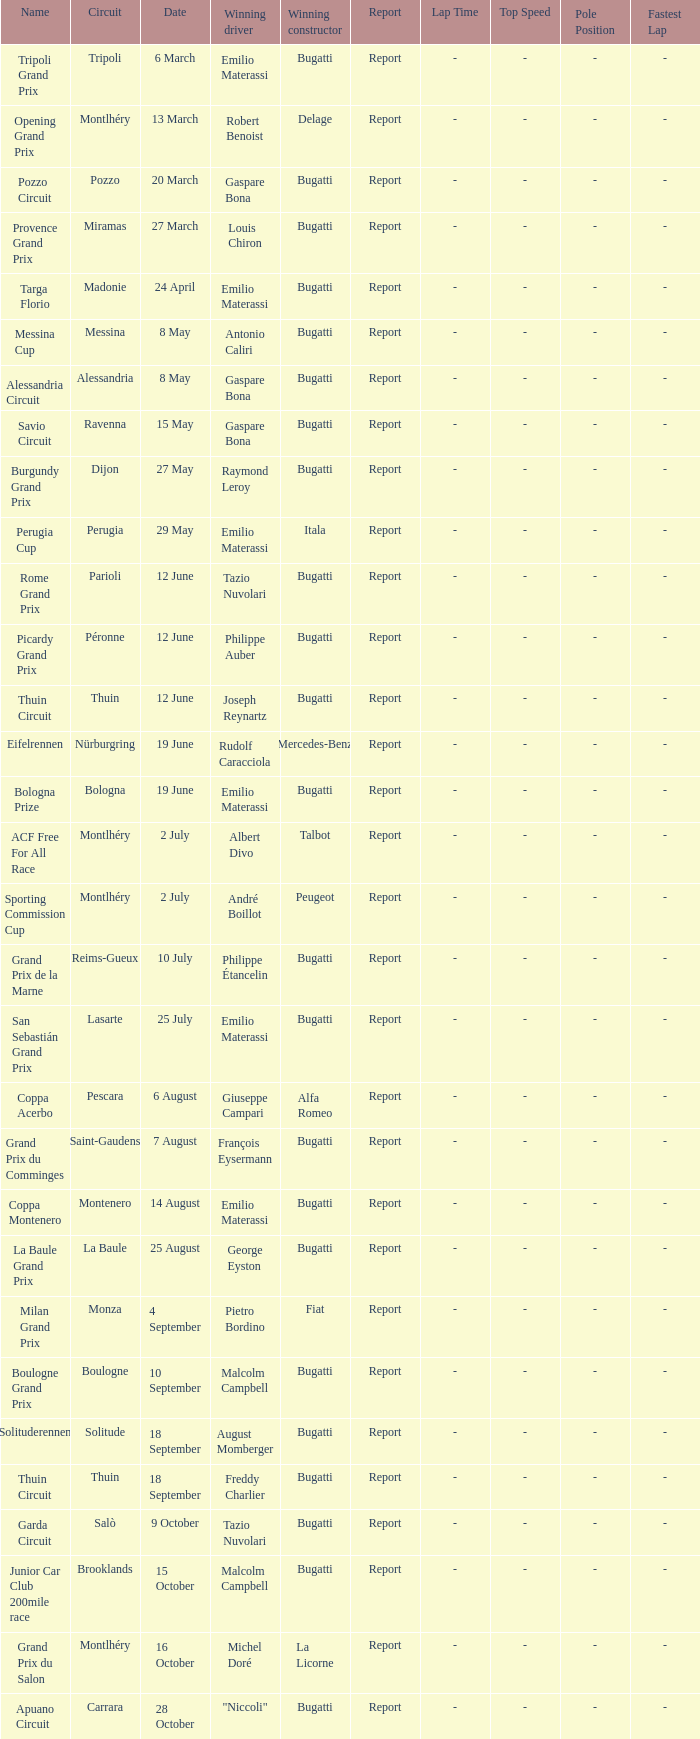Who was the winning constructor at the circuit of parioli? Bugatti. 